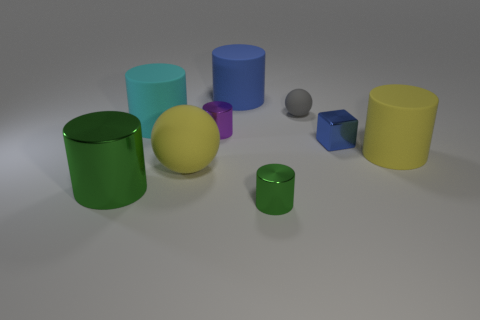How many brown balls have the same material as the tiny gray thing?
Provide a short and direct response. 0. There is a yellow matte object that is to the left of the small purple cylinder; does it have the same shape as the large blue object?
Offer a terse response. No. What shape is the matte object on the left side of the yellow ball?
Give a very brief answer. Cylinder. The cylinder that is the same color as the cube is what size?
Provide a short and direct response. Large. What is the material of the big cyan thing?
Make the answer very short. Rubber. What is the color of the metallic cylinder that is the same size as the blue rubber thing?
Make the answer very short. Green. What shape is the big matte object that is the same color as the metallic block?
Make the answer very short. Cylinder. Is the shape of the gray rubber object the same as the large green object?
Make the answer very short. No. The object that is on the left side of the gray thing and behind the cyan cylinder is made of what material?
Offer a terse response. Rubber. The cyan rubber object has what size?
Your answer should be very brief. Large. 